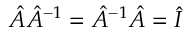<formula> <loc_0><loc_0><loc_500><loc_500>{ \hat { A } } { \hat { A } } ^ { - 1 } = { \hat { A } } ^ { - 1 } { \hat { A } } = { \hat { I } }</formula> 